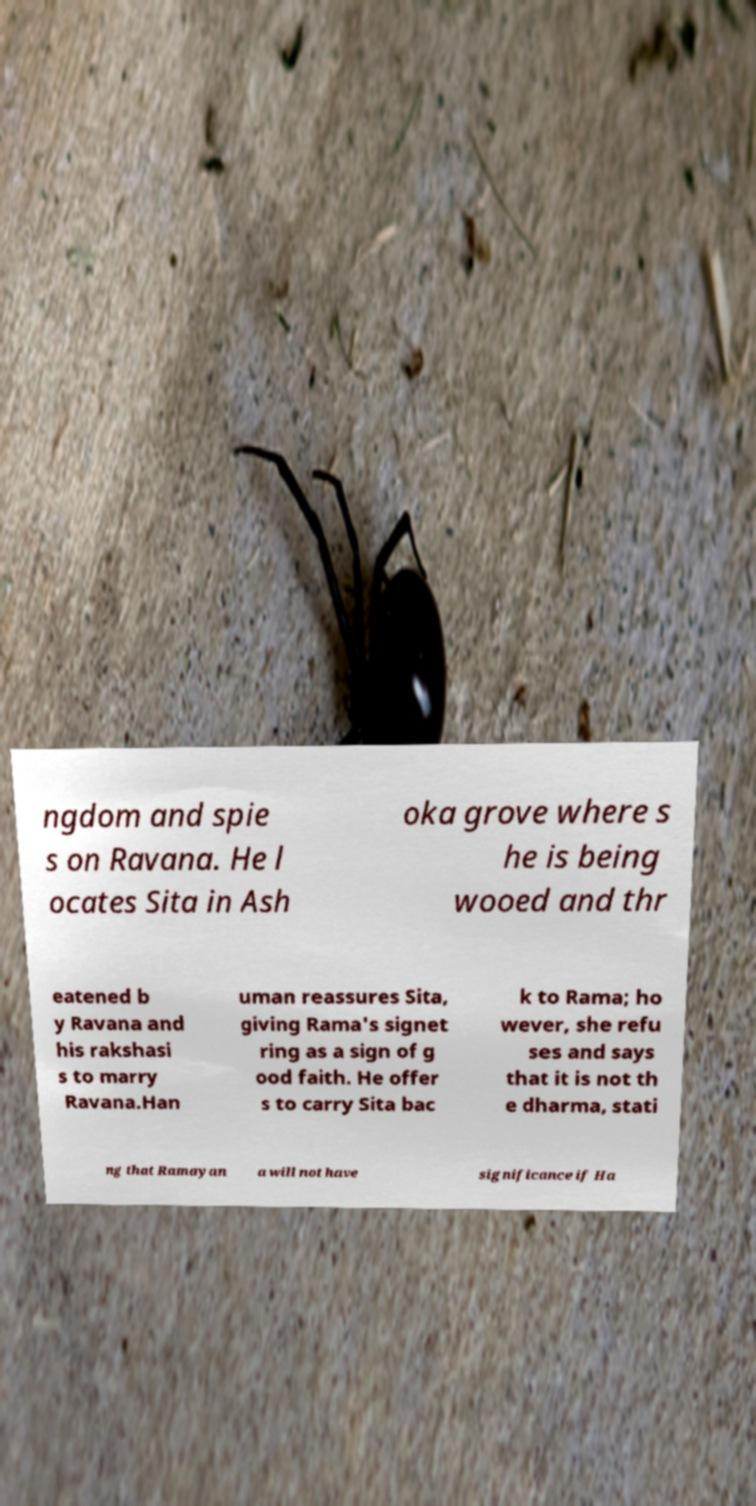Can you read and provide the text displayed in the image?This photo seems to have some interesting text. Can you extract and type it out for me? ngdom and spie s on Ravana. He l ocates Sita in Ash oka grove where s he is being wooed and thr eatened b y Ravana and his rakshasi s to marry Ravana.Han uman reassures Sita, giving Rama's signet ring as a sign of g ood faith. He offer s to carry Sita bac k to Rama; ho wever, she refu ses and says that it is not th e dharma, stati ng that Ramayan a will not have significance if Ha 